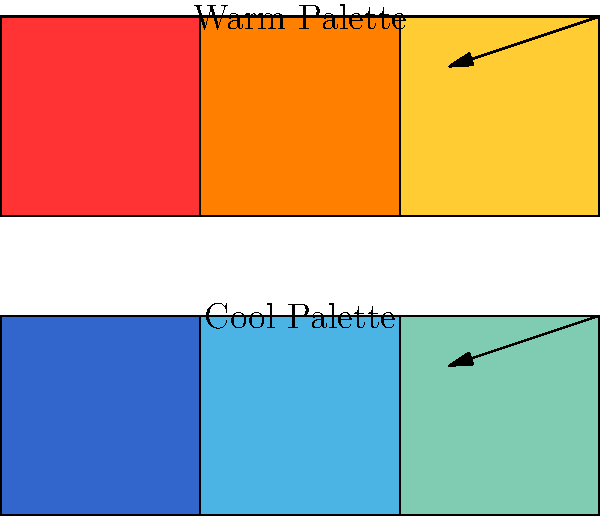In depicting war scenes through your artwork, how might the emotional impact differ when using a warm color palette (top) versus a cool color palette (bottom)? Consider the psychological associations of these color temperatures in relation to the trauma and hope experienced in war. To answer this question, let's break down the emotional impacts of warm and cool color palettes in the context of war scenes:

1. Warm Color Palette (Top):
   a) Consists of reds, oranges, and yellows
   b) Often associated with:
      - Heat, fire, and blood
      - Intensity, anger, and aggression
      - Danger and warning
   c) In war scenes, may evoke:
      - The immediacy and urgency of conflict
      - The passion and fervor of those involved
      - The heat and destruction of battle

2. Cool Color Palette (Bottom):
   a) Consists of blues, greens, and purples
   b) Often associated with:
      - Water, sky, and nature
      - Calmness, serenity, and tranquility
      - Distance and reflection
   c) In war scenes, may evoke:
      - The aftermath and reflection on conflict
      - The sadness and melancholy of loss
      - The hope for peace and healing

3. Emotional Impact in War Scenes:
   a) Warm palette:
      - More likely to depict the active, violent aspects of war
      - May trigger stronger, more immediate emotional responses
      - Could represent the trauma and horror experienced during conflict
   b) Cool palette:
      - More likely to depict the contemplative, reflective aspects of war
      - May evoke a sense of distance or emotional processing
      - Could represent hope for peace and the healing process after conflict

4. Artistic Choice:
   - The choice between warm and cool palettes can dramatically alter the viewer's emotional response
   - Warm palettes may be more effective in conveying the immediate trauma of war
   - Cool palettes may be more suitable for expressing hope and advocating for peace

5. Personal Experience:
   - As someone who has experienced the horrors of war, your choice of palette can reflect your journey from trauma to advocacy
   - Combining both palettes could represent the complex emotions associated with war and peace
Answer: Warm palette evokes immediate trauma and intensity of war; cool palette suggests reflection, sadness, and hope for peace. 